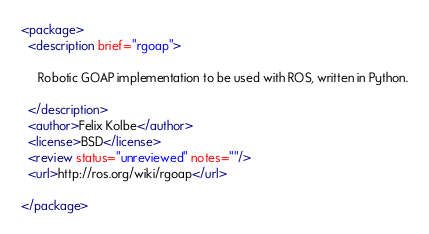<code> <loc_0><loc_0><loc_500><loc_500><_XML_><package>
  <description brief="rgoap">

     Robotic GOAP implementation to be used with ROS, written in Python.

  </description>
  <author>Felix Kolbe</author>
  <license>BSD</license>
  <review status="unreviewed" notes=""/>
  <url>http://ros.org/wiki/rgoap</url>

</package>
</code> 